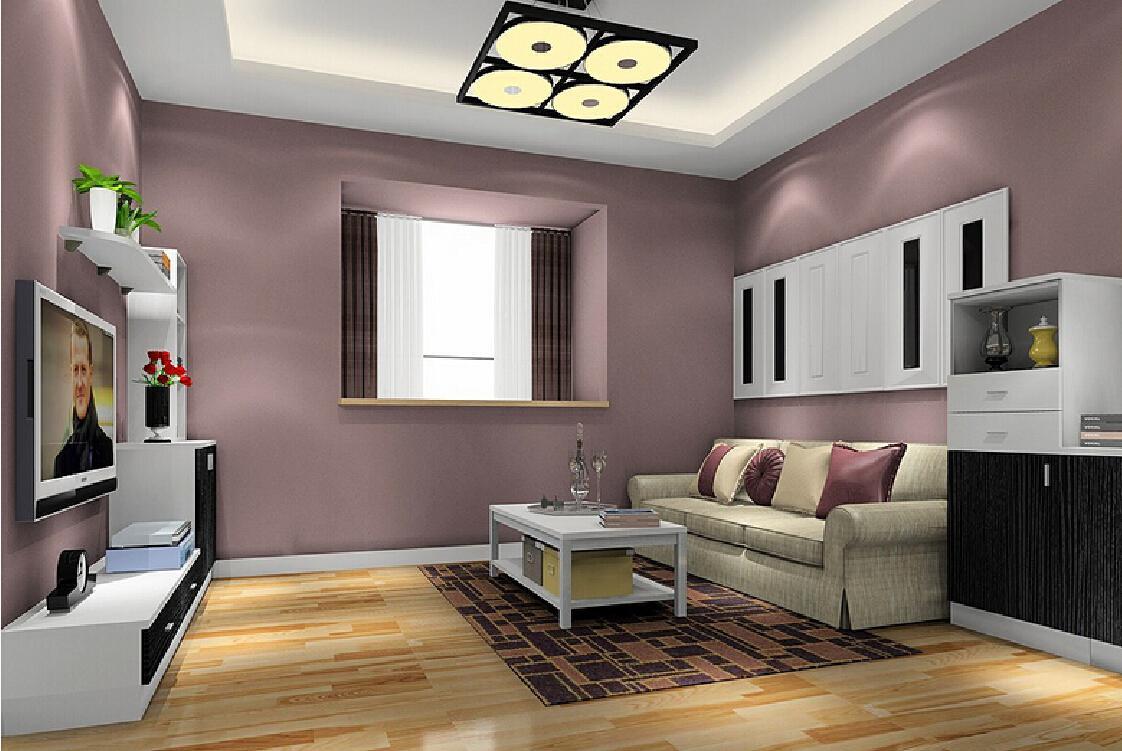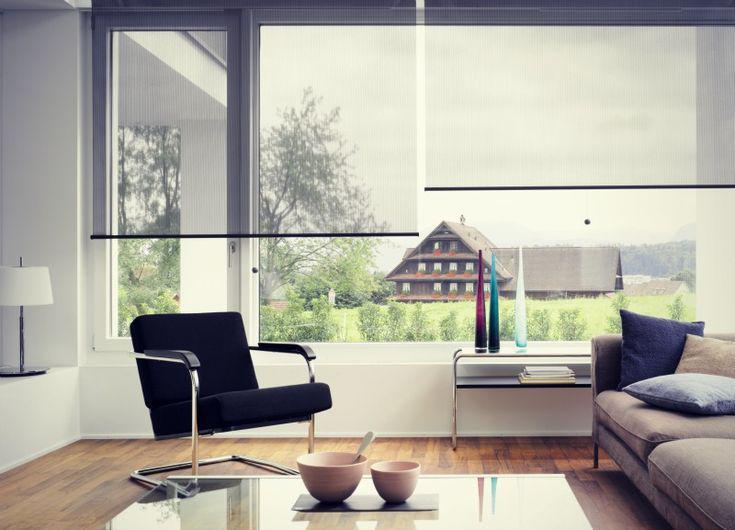The first image is the image on the left, the second image is the image on the right. For the images displayed, is the sentence "In at least one image there are three blinds with two at the same height." factually correct? Answer yes or no. No. 